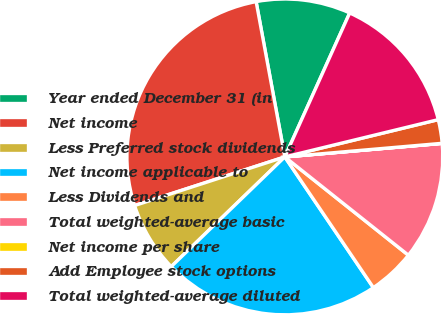Convert chart. <chart><loc_0><loc_0><loc_500><loc_500><pie_chart><fcel>Year ended December 31 (in<fcel>Net income<fcel>Less Preferred stock dividends<fcel>Net income applicable to<fcel>Less Dividends and<fcel>Total weighted-average basic<fcel>Net income per share<fcel>Add Employee stock options<fcel>Total weighted-average diluted<nl><fcel>9.65%<fcel>27.08%<fcel>7.24%<fcel>22.26%<fcel>4.83%<fcel>12.06%<fcel>0.01%<fcel>2.42%<fcel>14.47%<nl></chart> 